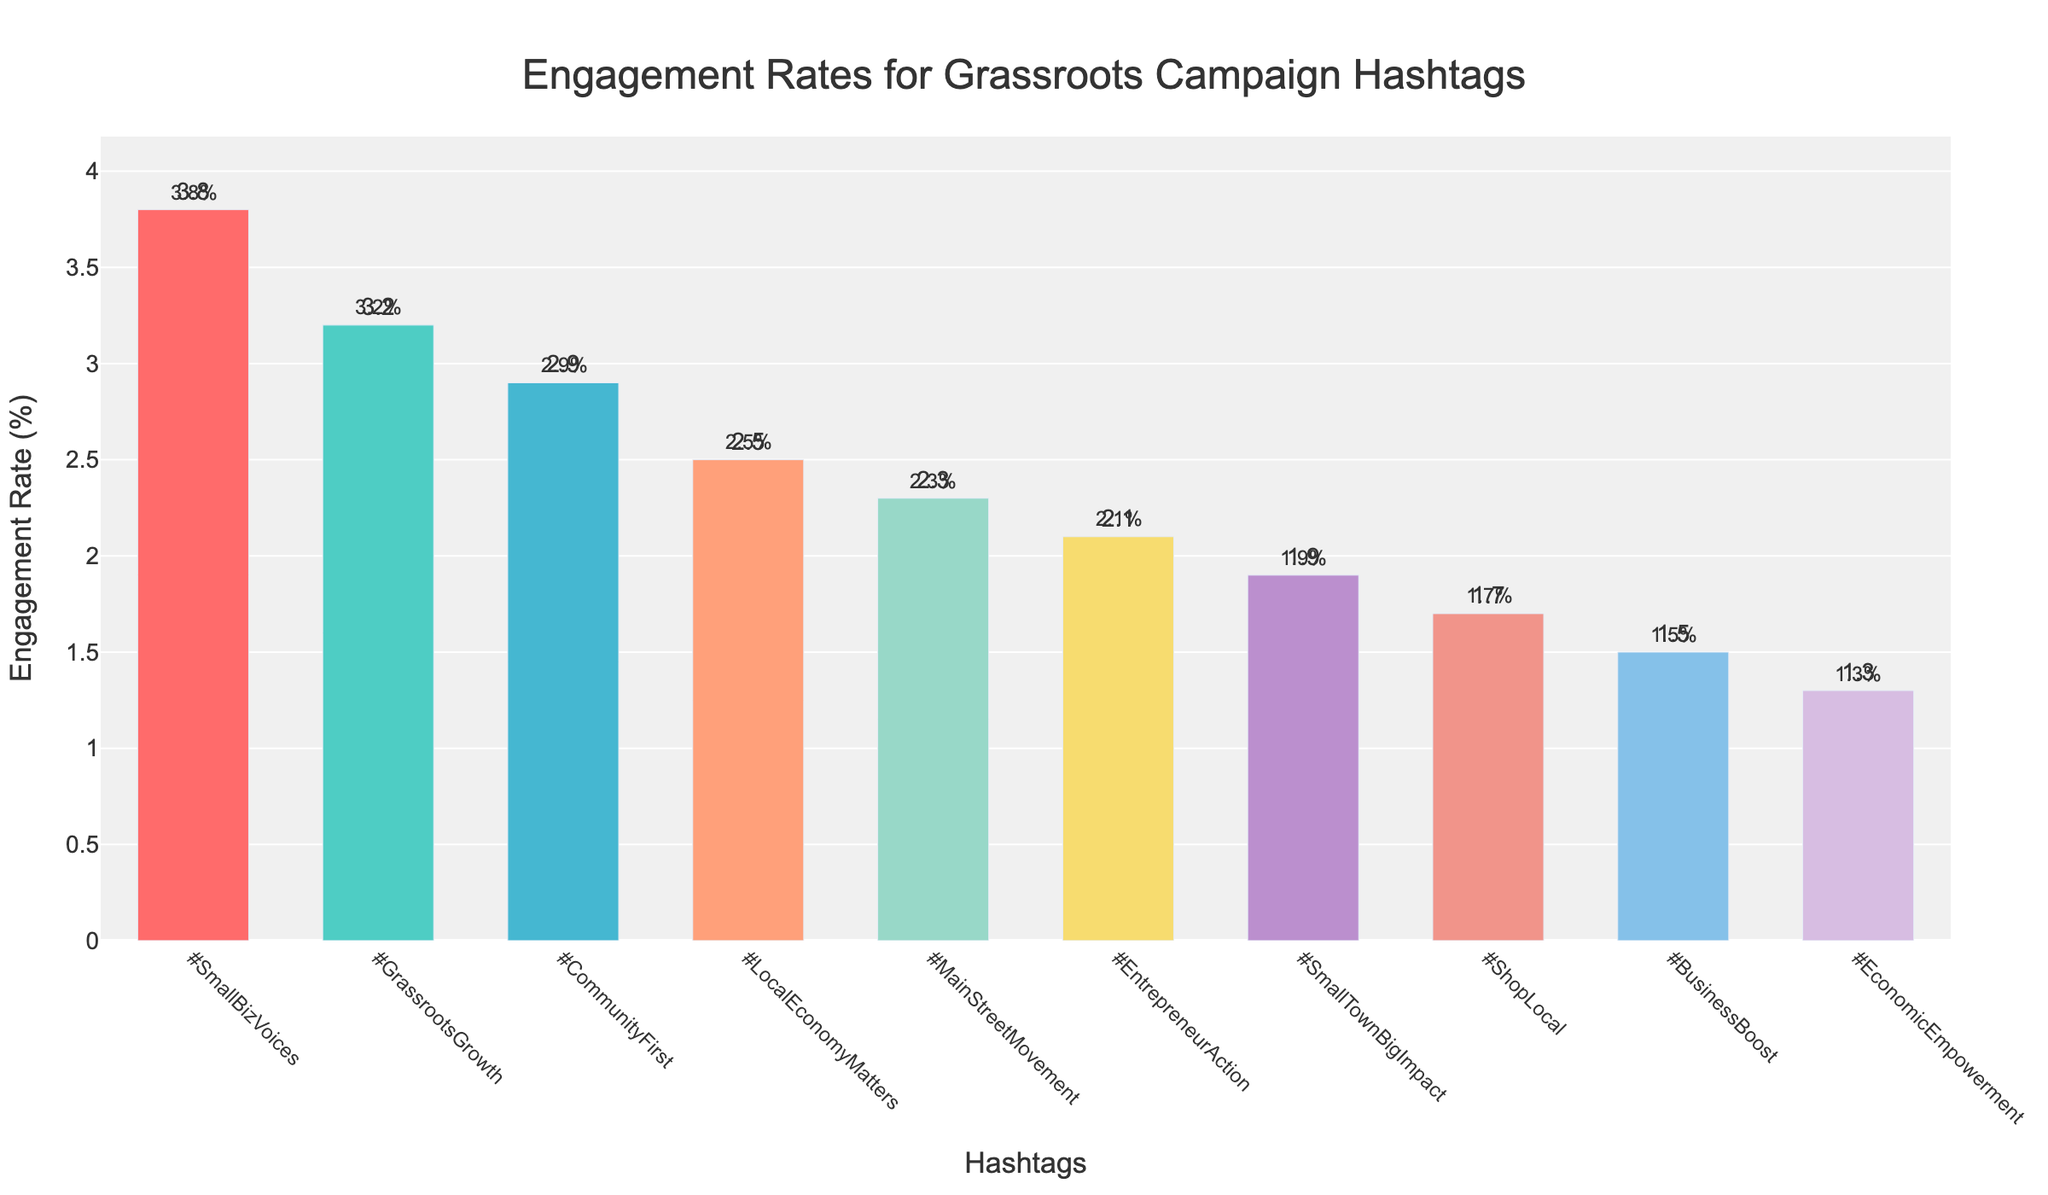Which hashtag has the highest engagement rate? By looking at the heights of the bars, #SmallBizVoices has the tallest bar, indicating the highest engagement rate.
Answer: #SmallBizVoices Which hashtag has the lowest engagement rate? The shortest bar corresponds to the hashtag with the lowest engagement rate, which is #EconomicEmpowerment.
Answer: #EconomicEmpowerment What is the difference in engagement rate between #SmallBizVoices and #EconomicEmpowerment? The engagement rate for #SmallBizVoices is 3.8%, and for #EconomicEmpowerment, it is 1.3%. The difference is calculated as 3.8% - 1.3% = 2.5%.
Answer: 2.5% Which hashtags have an engagement rate greater than 2.0%? By examining the bars, the hashtags with engagement rates above 2.0% are #SmallBizVoices, #GrassrootsGrowth, #CommunityFirst, and #LocalEconomyMatters.
Answer: #SmallBizVoices, #GrassrootsGrowth, #CommunityFirst, #LocalEconomyMatters How many hashtags have an engagement rate below 2.5%? By counting the bars with heights below the 2.5% mark, there are six hashtags: #MainStreetMovement, #EntrepreneurAction, #SmallTownBigImpact, #ShopLocal, #BusinessBoost, and #EconomicEmpowerment.
Answer: 6 What is the average engagement rate of the top three hashtags? The engagement rates of the top three hashtags are 3.8% for #SmallBizVoices, 3.2% for #GrassrootsGrowth, and 2.9% for #CommunityFirst. The average is calculated as (3.8 + 3.2 + 2.9)/3 = 9.9/3 = 3.3%.
Answer: 3.3% Is the engagement rate of #CommunityFirst closer to that of #GrassrootsGrowth or #LocalEconomyMatters? The engagement rate of #CommunityFirst is 2.9%. #GrassrootsGrowth has an engagement rate of 3.2%, and #LocalEconomyMatters has an engagement rate of 2.5%. The difference between 2.9% and 3.2% is 0.3%, and the difference between 2.9% and 2.5% is 0.4%. Therefore, #CommunityFirst's engagement rate is closer to that of #GrassrootsGrowth.
Answer: #GrassrootsGrowth What is the median engagement rate of the hashtags? To find the median, we need to list all engagement rates in order: 1.3, 1.5, 1.7, 1.9, 2.1, 2.3, 2.5, 2.9, 3.2, 3.8. The middle value in this ordered list (5th and 6th) is the average of 2.1 and 2.3. So the median is (2.1 + 2.3) / 2 = 2.2%.
Answer: 2.2% Are there more hashtags with an engagement rate above or below 2.0%? By counting the bars, there are 4 hashtags with engagement rates above 2.0% (#SmallBizVoices, #GrassrootsGrowth, #CommunityFirst, #LocalEconomyMatters) and 6 hashtags with engagement rates below 2.0% (#MainStreetMovement, #EntrepreneurAction, #SmallTownBigImpact, #ShopLocal, #BusinessBoost, #EconomicEmpowerment).
Answer: Below 2.0% 